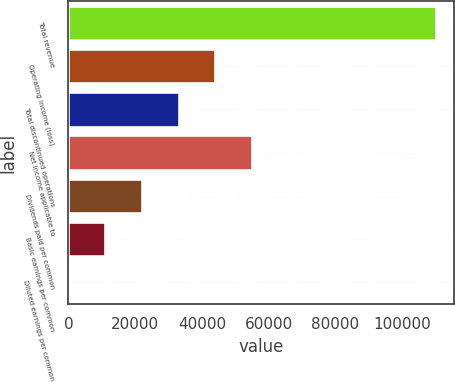Convert chart to OTSL. <chart><loc_0><loc_0><loc_500><loc_500><bar_chart><fcel>Total revenue<fcel>Operating income (loss)<fcel>Total discontinued operations<fcel>Net income applicable to<fcel>Dividends paid per common<fcel>Basic earnings per common<fcel>Diluted earnings per common<nl><fcel>110115<fcel>44046.1<fcel>33034.7<fcel>55057.6<fcel>22023.2<fcel>11011.7<fcel>0.26<nl></chart> 